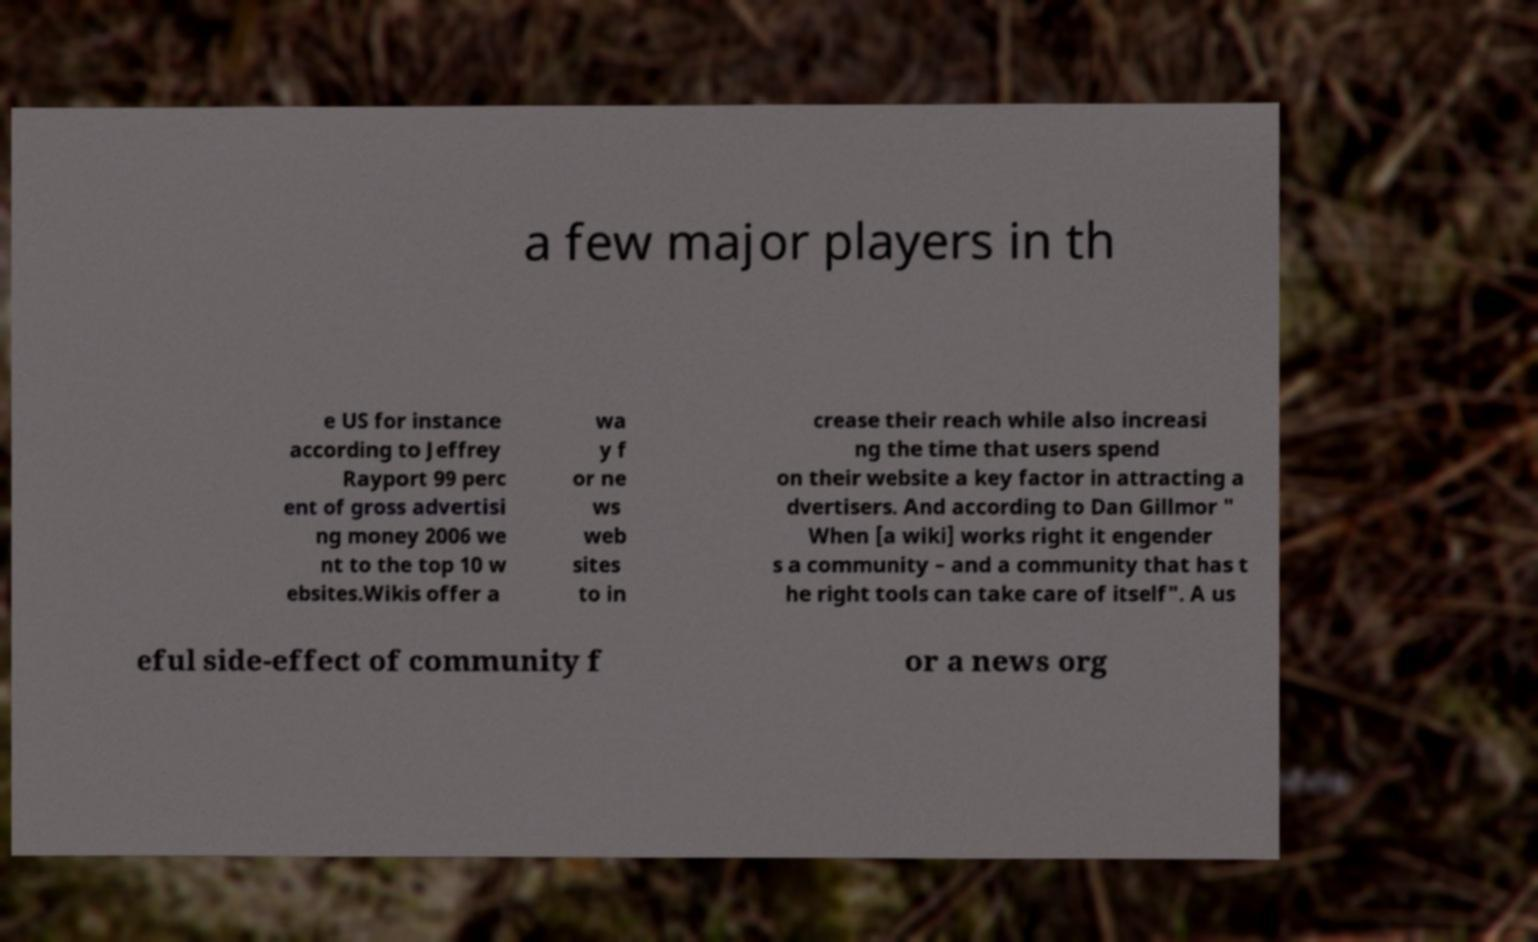What messages or text are displayed in this image? I need them in a readable, typed format. a few major players in th e US for instance according to Jeffrey Rayport 99 perc ent of gross advertisi ng money 2006 we nt to the top 10 w ebsites.Wikis offer a wa y f or ne ws web sites to in crease their reach while also increasi ng the time that users spend on their website a key factor in attracting a dvertisers. And according to Dan Gillmor " When [a wiki] works right it engender s a community – and a community that has t he right tools can take care of itself". A us eful side-effect of community f or a news org 